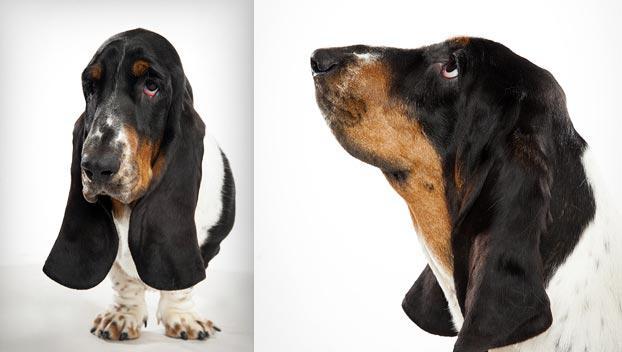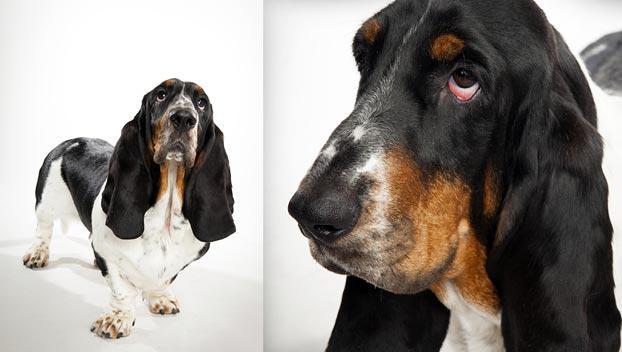The first image is the image on the left, the second image is the image on the right. Examine the images to the left and right. Is the description "A non-collage image shows two animals side-by-side, at least one of them a basset hound." accurate? Answer yes or no. No. The first image is the image on the left, the second image is the image on the right. Given the left and right images, does the statement "Each photo contains a single dog." hold true? Answer yes or no. No. 